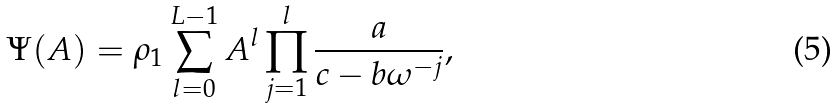<formula> <loc_0><loc_0><loc_500><loc_500>\Psi ( A ) = \rho _ { 1 } \sum _ { l = 0 } ^ { L - 1 } A ^ { l } \prod _ { j = 1 } ^ { l } \frac { a } { c - b \omega ^ { - j } } ,</formula> 